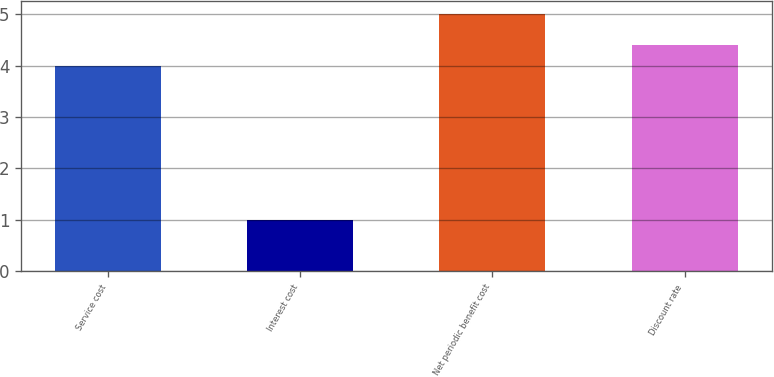<chart> <loc_0><loc_0><loc_500><loc_500><bar_chart><fcel>Service cost<fcel>Interest cost<fcel>Net periodic benefit cost<fcel>Discount rate<nl><fcel>4<fcel>1<fcel>5<fcel>4.4<nl></chart> 